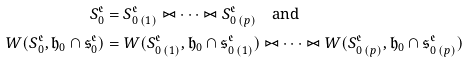<formula> <loc_0><loc_0><loc_500><loc_500>S _ { 0 } ^ { \mathfrak { e } } & = { S } _ { 0 \, ( 1 ) } ^ { \mathfrak { e } } \bowtie \cdots \bowtie { S } _ { 0 \, ( p ) } ^ { \mathfrak { e } } \quad \text {and} \quad \\ W ( S _ { 0 } ^ { \mathfrak { e } } , \mathfrak { h } _ { 0 } \cap \mathfrak { s } _ { 0 } ^ { \mathfrak { e } } ) & = W ( { S } _ { 0 \, ( 1 ) } ^ { \mathfrak { e } } , \mathfrak { h } _ { 0 } \cap \mathfrak { s } _ { 0 \, ( 1 ) } ^ { \mathfrak { e } } ) \bowtie \cdots \bowtie W ( { S } _ { 0 \, ( p ) } ^ { \mathfrak { e } } , \mathfrak { h } _ { 0 } \cap \mathfrak { s } _ { 0 \, ( p ) } ^ { \mathfrak { e } } )</formula> 